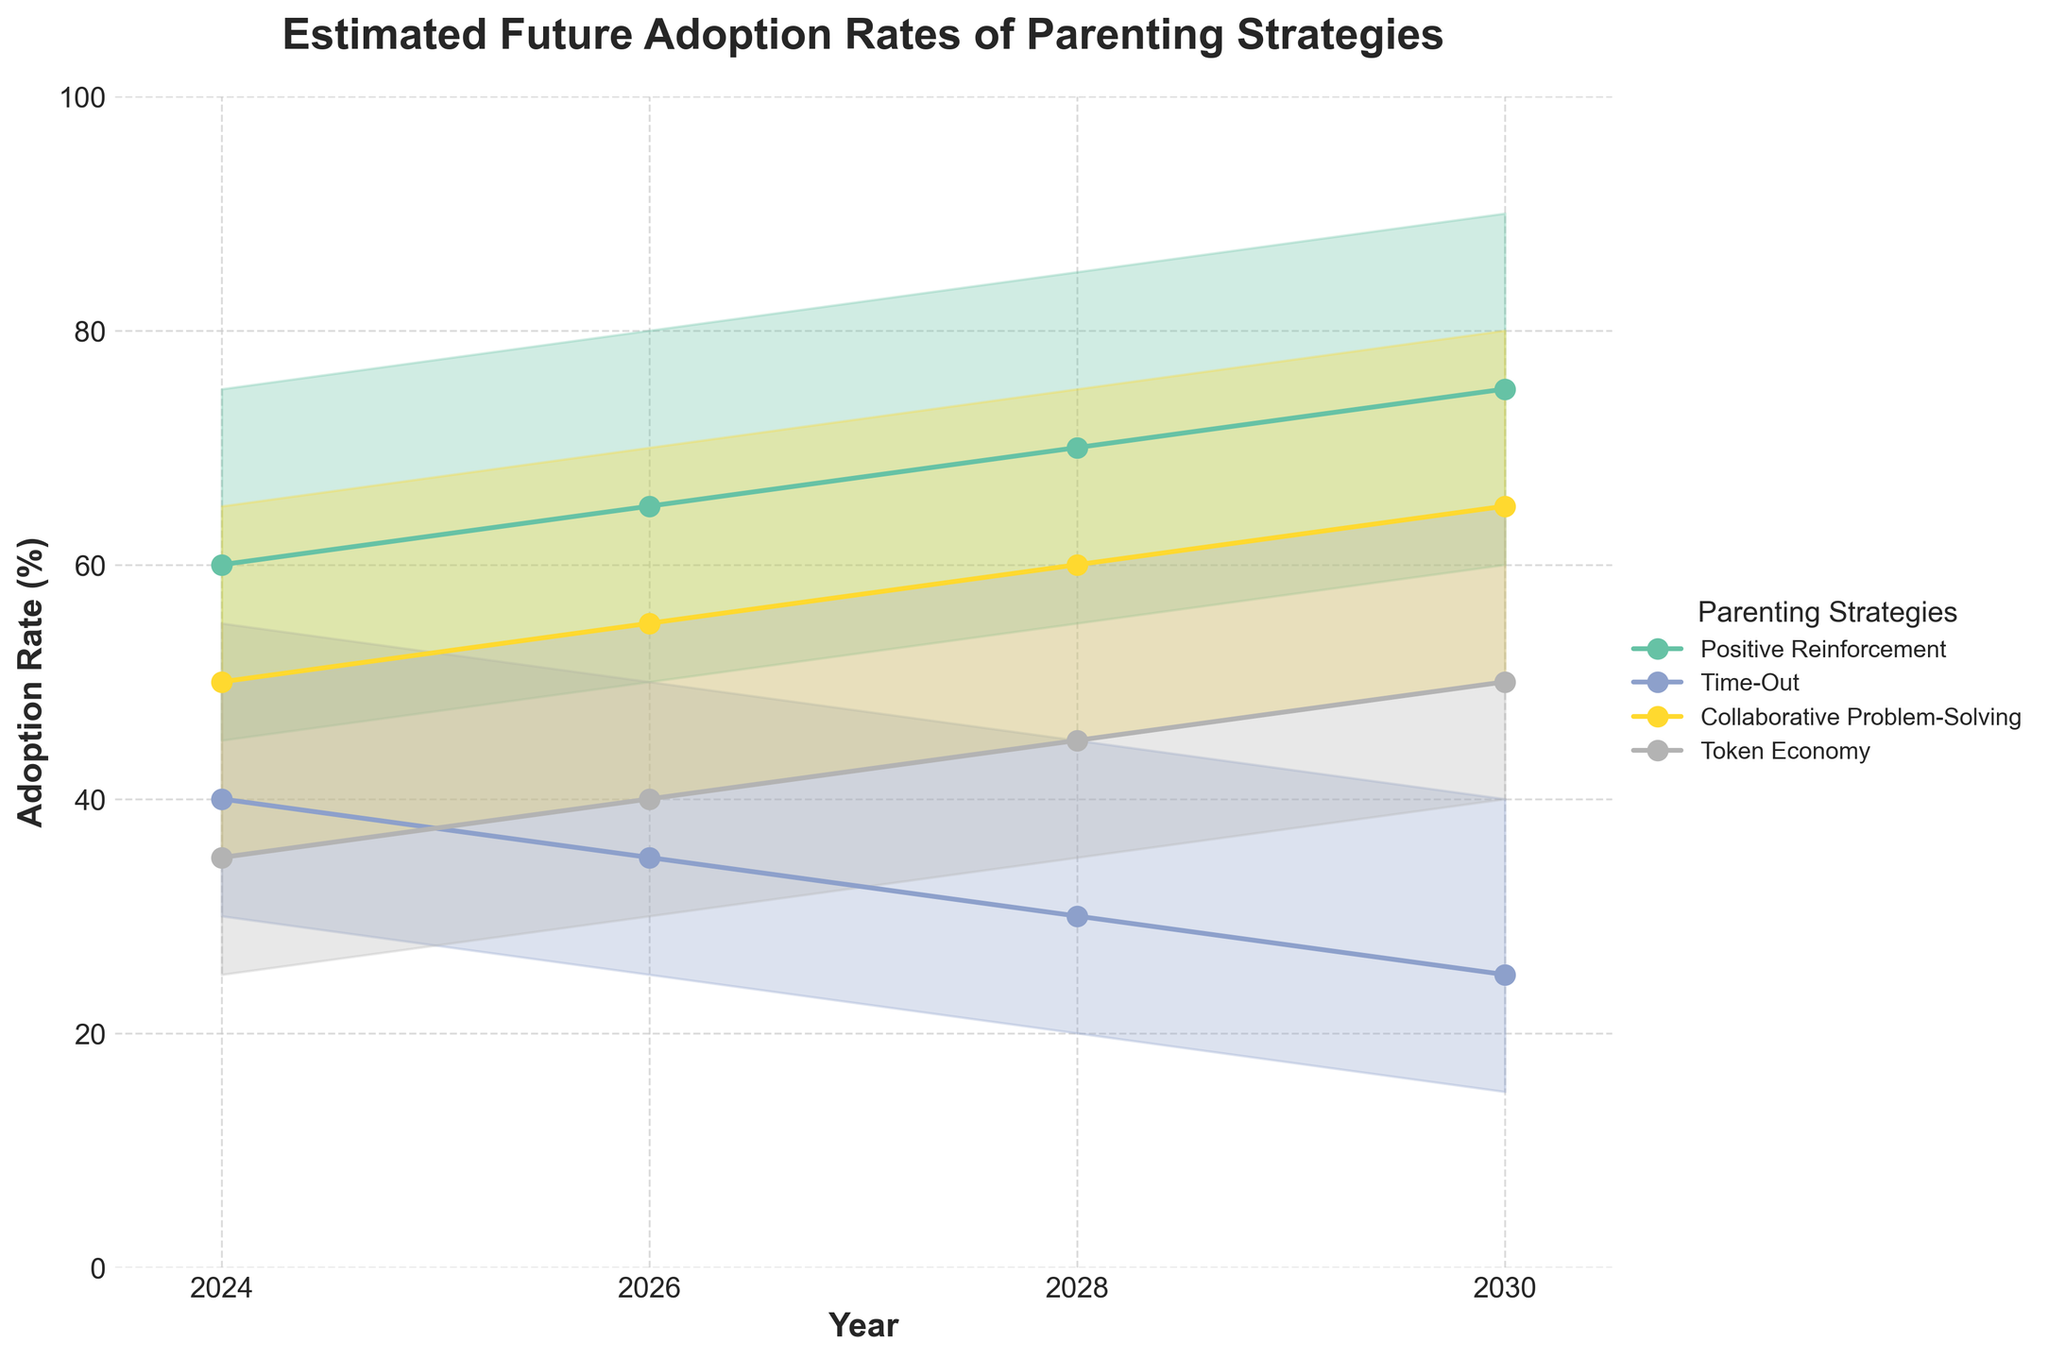What is the title of the figure? The title is displayed at the top of the figure, and it is typically the largest text. It summarizes the entire chart.
Answer: Estimated Future Adoption Rates of Parenting Strategies Which strategy has the highest likely adoption rate in 2024? To find the highest likely adoption rate for 2024, compare the "Likely" values for all strategies for that year. Positive Reinforcement has a likely adoption rate of 60, which is the highest among the listed strategies.
Answer: Positive Reinforcement How does the likely adoption rate of Token Economy change from 2024 to 2030? Identify the likely adoption rates of Token Economy for 2024 and 2030, which are 35 and 50, respectively. Calculate the difference: 50 - 35 = 15. The likely adoption rate increased by 15%.
Answer: Increased by 15% Which parenting strategy shows the most significant drop in its likely adoption rate from 2024 to 2030? Compare the likely rates for all strategies in 2024 and 2030. Time-Out shows a decrease from 40 to 25, which is the largest drop of 15 percentage points.
Answer: Time-Out For which year is the range of adoption rates for Positive Reinforcement the widest? Determine the range for each year by subtracting the Low rate from the High rate. For Positive Reinforcement: 2024 (75-45=30), 2026 (80-50=30), 2028 (85-55=30), 2030 (90-60=30). The range remains constant at 30 across all years.
Answer: 2024, 2026, 2028, and 2030 Which strategy is expected to have the lowest likely adoption rate in 2030? Check the likely adoption rates for all strategies in 2030. Time-Out, with a likely rate of 25, is the lowest among the strategies.
Answer: Time-Out In 2028, which two strategies have the closest likely adoption rates, and what is the difference between them? Compare the likely adoption rates for all strategies in 2028. Collaborative Problem-Solving (60) and Token Economy (45) are the closest. The difference is 60 - 45 = 15.
Answer: Collaborative Problem-Solving and Token Economy, 15 Between 2024 and 2026, which strategy shows the greatest percent increase in its likely adoption rate? Calculate the percent increase for each strategy from 2024 to 2026: Positive Reinforcement ((65-60)/60)*100 = 8.33%, Time-Out ((35-40)/40)*100 = -12.5%, Collaborative Problem-Solving ((55-50)/50)*100 = 10%, Token Economy ((40-35)/35)*100 = 14.29%. Token Economy has the greatest percent increase.
Answer: Token Economy, 14.29% What is the average likely adoption rate of Collaborative Problem-Solving over the years listed? Sum the likely values for Collaborative Problem-Solving (50+55+60+65=230) and divide by the number of years (230/4).
Answer: 57.5 Which year shows the lowest range for adoption rates across all strategies? Calculate the range (high-low) for each year across all strategies. For 2024: 75-25=50, 2026: 80-25=55, 2028: 85-20=65, 2030: 90-15=75. The lowest range is for 2024.
Answer: 2024 